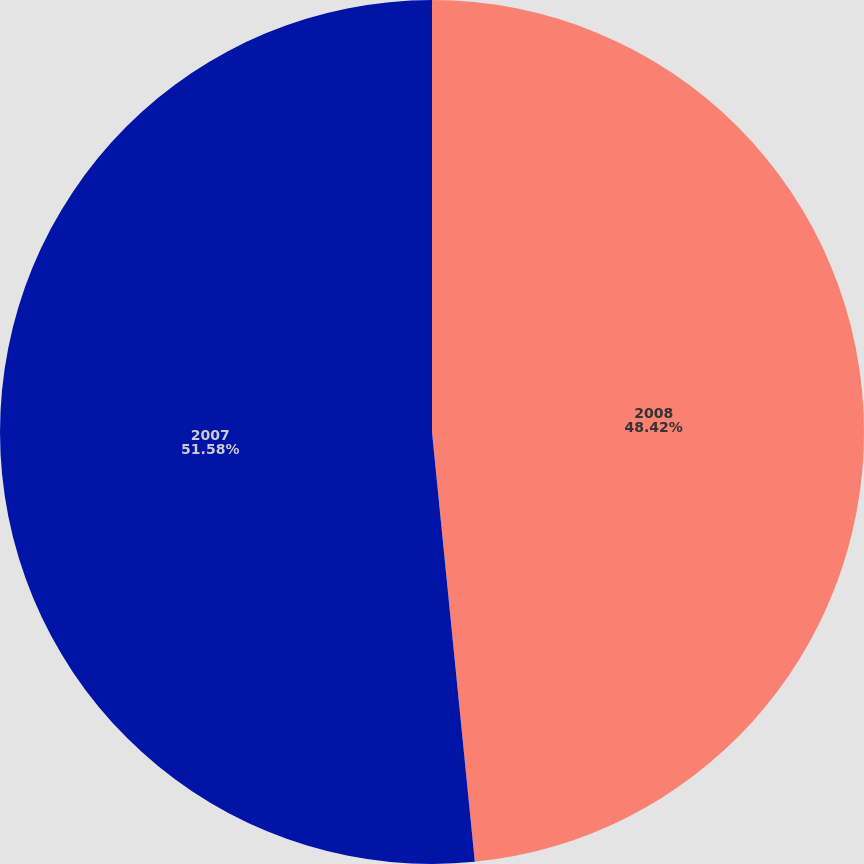<chart> <loc_0><loc_0><loc_500><loc_500><pie_chart><fcel>2008<fcel>2007<nl><fcel>48.42%<fcel>51.58%<nl></chart> 